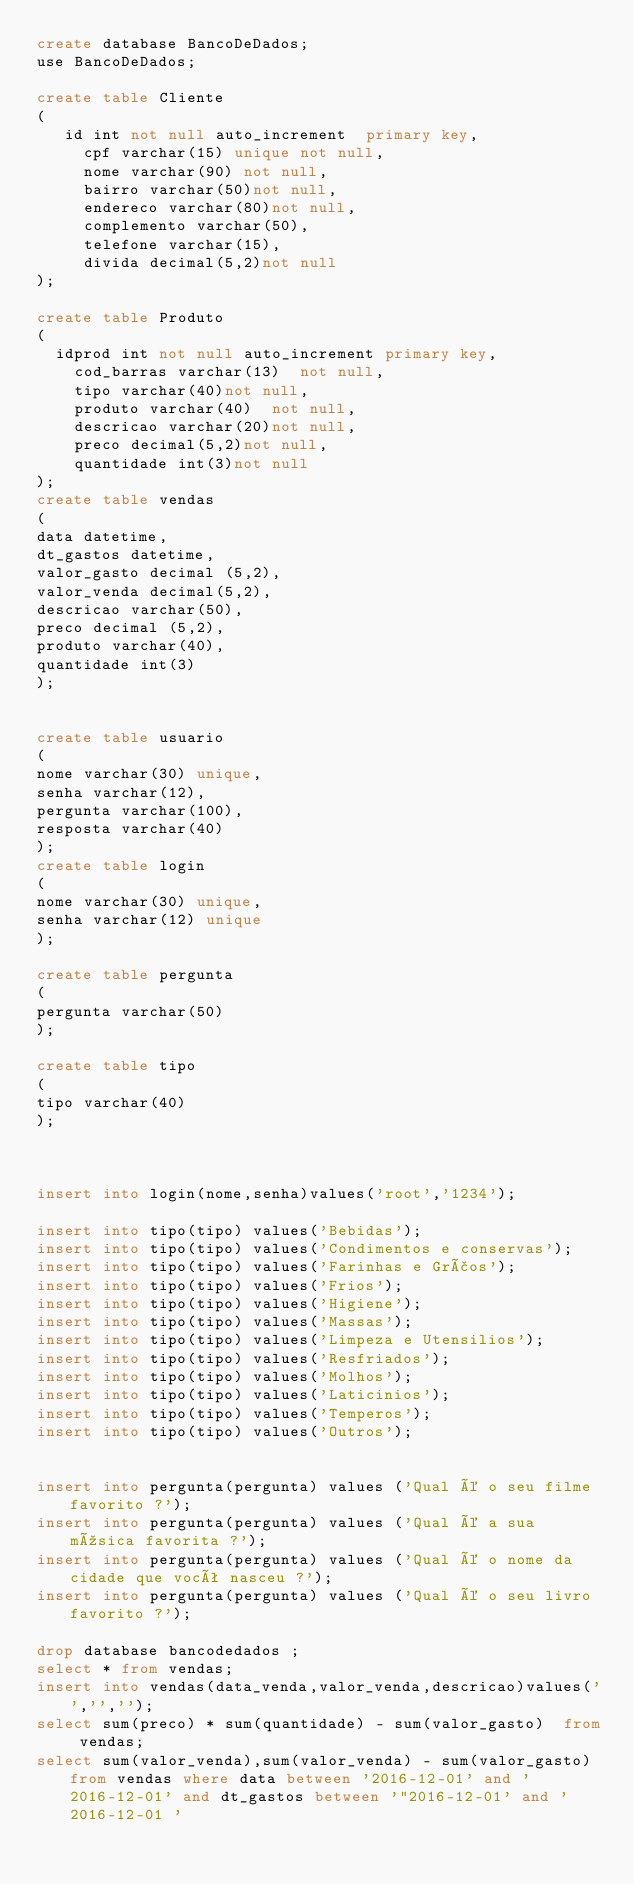<code> <loc_0><loc_0><loc_500><loc_500><_SQL_>create database BancoDeDados;
use BancoDeDados;

create table Cliente
(
	 id int not null auto_increment  primary key,
     cpf varchar(15) unique not null,
     nome varchar(90) not null,
     bairro varchar(50)not null,
     endereco varchar(80)not null,
     complemento varchar(50),
     telefone varchar(15),
     divida decimal(5,2)not null
);

create table Produto
(
	idprod int not null auto_increment primary key,
    cod_barras varchar(13)  not null,
    tipo varchar(40)not null,
    produto varchar(40)  not null,
    descricao varchar(20)not null,
    preco decimal(5,2)not null,
    quantidade int(3)not null
);
create table vendas
(
data datetime,
dt_gastos datetime,
valor_gasto decimal (5,2),
valor_venda decimal(5,2),
descricao varchar(50),
preco decimal (5,2),
produto varchar(40),
quantidade int(3)
);


create table usuario
(
nome varchar(30) unique,
senha varchar(12),
pergunta varchar(100),
resposta varchar(40)
);
create table login
(
nome varchar(30) unique,
senha varchar(12) unique
);

create table pergunta
(
pergunta varchar(50)
);

create table tipo
(
tipo varchar(40) 
);



insert into login(nome,senha)values('root','1234');

insert into tipo(tipo) values('Bebidas');
insert into tipo(tipo) values('Condimentos e conservas');
insert into tipo(tipo) values('Farinhas e Grãos');
insert into tipo(tipo) values('Frios');
insert into tipo(tipo) values('Higiene');
insert into tipo(tipo) values('Massas');
insert into tipo(tipo) values('Limpeza e Utensilios');
insert into tipo(tipo) values('Resfriados');
insert into tipo(tipo) values('Molhos');
insert into tipo(tipo) values('Laticinios');
insert into tipo(tipo) values('Temperos');
insert into tipo(tipo) values('Outros');


insert into pergunta(pergunta) values ('Qual é o seu filme favorito ?');
insert into pergunta(pergunta) values ('Qual é a sua música favorita ?');
insert into pergunta(pergunta) values ('Qual é o nome da cidade que você nasceu ?');
insert into pergunta(pergunta) values ('Qual é o seu livro favorito ?');

drop database bancodedados ;
select * from vendas;
insert into vendas(data_venda,valor_venda,descricao)values('','','');
select sum(preco) * sum(quantidade) - sum(valor_gasto)  from vendas;
select sum(valor_venda),sum(valor_venda) - sum(valor_gasto) from vendas where data between '2016-12-01' and '2016-12-01' and dt_gastos between '"2016-12-01' and ' 2016-12-01 '</code> 